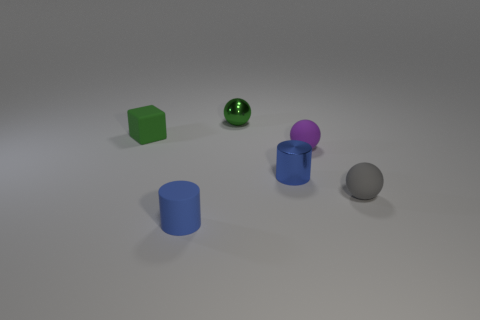Could you describe the lighting of the scene and how it influences the perception of the objects? The lighting in this scene seems to be coming from above, casting a soft and diffuse illumination that enhances the three-dimensionality of the objects. It creates subtle shadows that ground the objects on the surface, while the highlights on the shiny metallic surfaces draw the eye and contribute to their perception as being glossy and reflective. The matte objects absorb light, making their colors appear more solid and less reflective. 